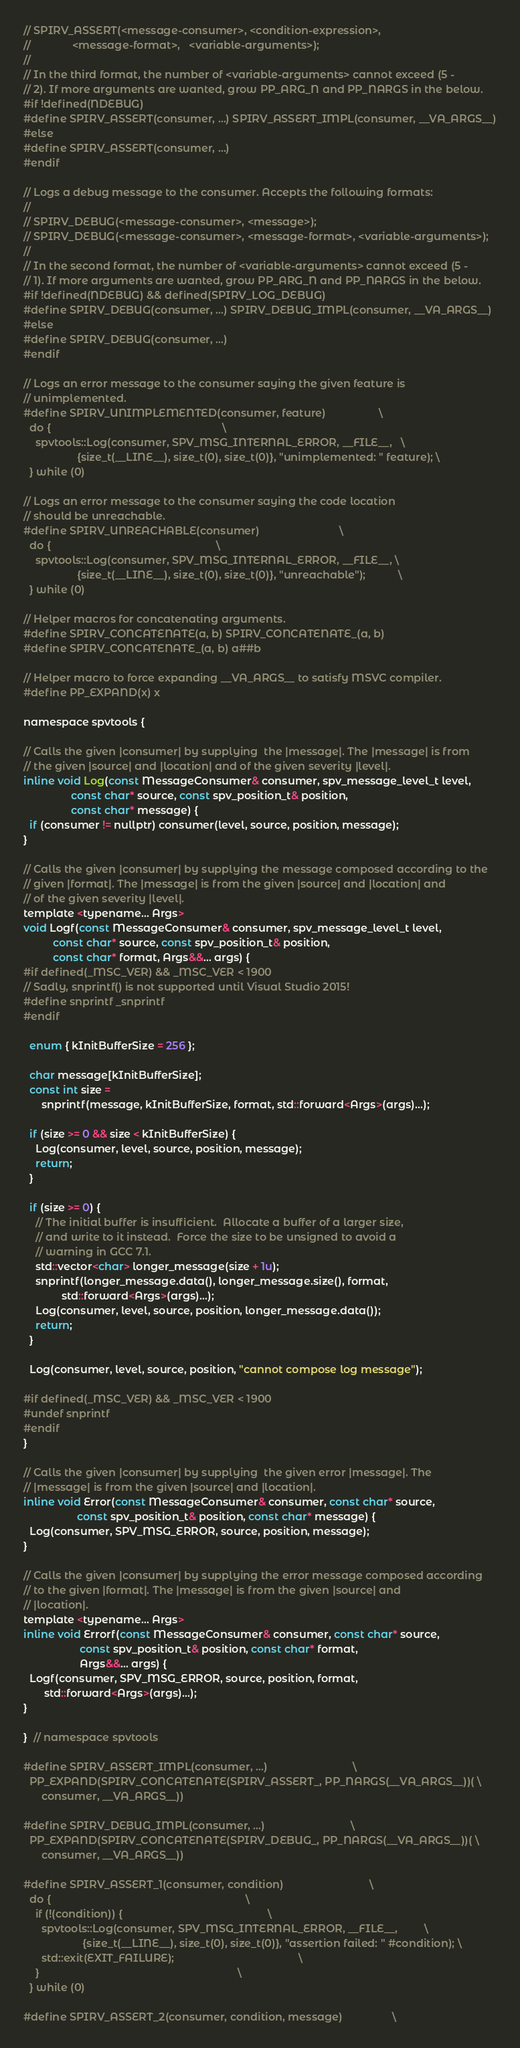Convert code to text. <code><loc_0><loc_0><loc_500><loc_500><_C_>// SPIRV_ASSERT(<message-consumer>, <condition-expression>,
//              <message-format>,   <variable-arguments>);
//
// In the third format, the number of <variable-arguments> cannot exceed (5 -
// 2). If more arguments are wanted, grow PP_ARG_N and PP_NARGS in the below.
#if !defined(NDEBUG)
#define SPIRV_ASSERT(consumer, ...) SPIRV_ASSERT_IMPL(consumer, __VA_ARGS__)
#else
#define SPIRV_ASSERT(consumer, ...)
#endif

// Logs a debug message to the consumer. Accepts the following formats:
//
// SPIRV_DEBUG(<message-consumer>, <message>);
// SPIRV_DEBUG(<message-consumer>, <message-format>, <variable-arguments>);
//
// In the second format, the number of <variable-arguments> cannot exceed (5 -
// 1). If more arguments are wanted, grow PP_ARG_N and PP_NARGS in the below.
#if !defined(NDEBUG) && defined(SPIRV_LOG_DEBUG)
#define SPIRV_DEBUG(consumer, ...) SPIRV_DEBUG_IMPL(consumer, __VA_ARGS__)
#else
#define SPIRV_DEBUG(consumer, ...)
#endif

// Logs an error message to the consumer saying the given feature is
// unimplemented.
#define SPIRV_UNIMPLEMENTED(consumer, feature)                  \
  do {                                                          \
    spvtools::Log(consumer, SPV_MSG_INTERNAL_ERROR, __FILE__,   \
                  {size_t(__LINE__), size_t(0), size_t(0)}, "unimplemented: " feature); \
  } while (0)

// Logs an error message to the consumer saying the code location
// should be unreachable.
#define SPIRV_UNREACHABLE(consumer)                           \
  do {                                                        \
    spvtools::Log(consumer, SPV_MSG_INTERNAL_ERROR, __FILE__, \
                  {size_t(__LINE__), size_t(0), size_t(0)}, "unreachable");           \
  } while (0)

// Helper macros for concatenating arguments.
#define SPIRV_CONCATENATE(a, b) SPIRV_CONCATENATE_(a, b)
#define SPIRV_CONCATENATE_(a, b) a##b

// Helper macro to force expanding __VA_ARGS__ to satisfy MSVC compiler.
#define PP_EXPAND(x) x

namespace spvtools {

// Calls the given |consumer| by supplying  the |message|. The |message| is from
// the given |source| and |location| and of the given severity |level|.
inline void Log(const MessageConsumer& consumer, spv_message_level_t level,
                const char* source, const spv_position_t& position,
                const char* message) {
  if (consumer != nullptr) consumer(level, source, position, message);
}

// Calls the given |consumer| by supplying the message composed according to the
// given |format|. The |message| is from the given |source| and |location| and
// of the given severity |level|.
template <typename... Args>
void Logf(const MessageConsumer& consumer, spv_message_level_t level,
          const char* source, const spv_position_t& position,
          const char* format, Args&&... args) {
#if defined(_MSC_VER) && _MSC_VER < 1900
// Sadly, snprintf() is not supported until Visual Studio 2015!
#define snprintf _snprintf
#endif

  enum { kInitBufferSize = 256 };

  char message[kInitBufferSize];
  const int size =
      snprintf(message, kInitBufferSize, format, std::forward<Args>(args)...);

  if (size >= 0 && size < kInitBufferSize) {
    Log(consumer, level, source, position, message);
    return;
  }

  if (size >= 0) {
    // The initial buffer is insufficient.  Allocate a buffer of a larger size,
    // and write to it instead.  Force the size to be unsigned to avoid a
    // warning in GCC 7.1.
    std::vector<char> longer_message(size + 1u);
    snprintf(longer_message.data(), longer_message.size(), format,
             std::forward<Args>(args)...);
    Log(consumer, level, source, position, longer_message.data());
    return;
  }

  Log(consumer, level, source, position, "cannot compose log message");

#if defined(_MSC_VER) && _MSC_VER < 1900
#undef snprintf
#endif
}

// Calls the given |consumer| by supplying  the given error |message|. The
// |message| is from the given |source| and |location|.
inline void Error(const MessageConsumer& consumer, const char* source,
                  const spv_position_t& position, const char* message) {
  Log(consumer, SPV_MSG_ERROR, source, position, message);
}

// Calls the given |consumer| by supplying the error message composed according
// to the given |format|. The |message| is from the given |source| and
// |location|.
template <typename... Args>
inline void Errorf(const MessageConsumer& consumer, const char* source,
                   const spv_position_t& position, const char* format,
                   Args&&... args) {
  Logf(consumer, SPV_MSG_ERROR, source, position, format,
       std::forward<Args>(args)...);
}

}  // namespace spvtools

#define SPIRV_ASSERT_IMPL(consumer, ...)                             \
  PP_EXPAND(SPIRV_CONCATENATE(SPIRV_ASSERT_, PP_NARGS(__VA_ARGS__))( \
      consumer, __VA_ARGS__))

#define SPIRV_DEBUG_IMPL(consumer, ...)                             \
  PP_EXPAND(SPIRV_CONCATENATE(SPIRV_DEBUG_, PP_NARGS(__VA_ARGS__))( \
      consumer, __VA_ARGS__))

#define SPIRV_ASSERT_1(consumer, condition)                             \
  do {                                                                  \
    if (!(condition)) {                                                 \
      spvtools::Log(consumer, SPV_MSG_INTERNAL_ERROR, __FILE__,         \
                    {size_t(__LINE__), size_t(0), size_t(0)}, "assertion failed: " #condition); \
      std::exit(EXIT_FAILURE);                                          \
    }                                                                   \
  } while (0)

#define SPIRV_ASSERT_2(consumer, condition, message)                 \</code> 